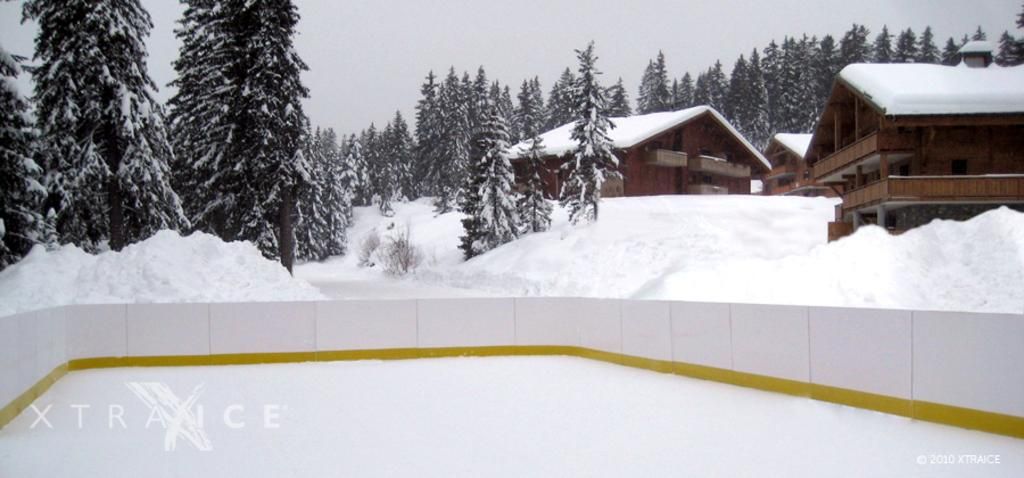What type of structure can be seen in the image? There is a fence wall in the image. What is the weather like in the image? Snow is visible in the image, indicating a cold or wintery weather. What type of vegetation is present in the image? There are many trees in the image. What color are the houses in the image? The houses in the image are brown in color. What else can be seen in the sky in the image? The sky is visible in the image, but no specific details about the sky are mentioned in the facts. How many cherries are hanging from the trees in the image? There is no mention of cherries in the image, so it is impossible to determine how many cherries are present. Is there a robin perched on the fence wall in the image? There is no mention of a robin or any birds in the image, so it is impossible to determine if one is present. 